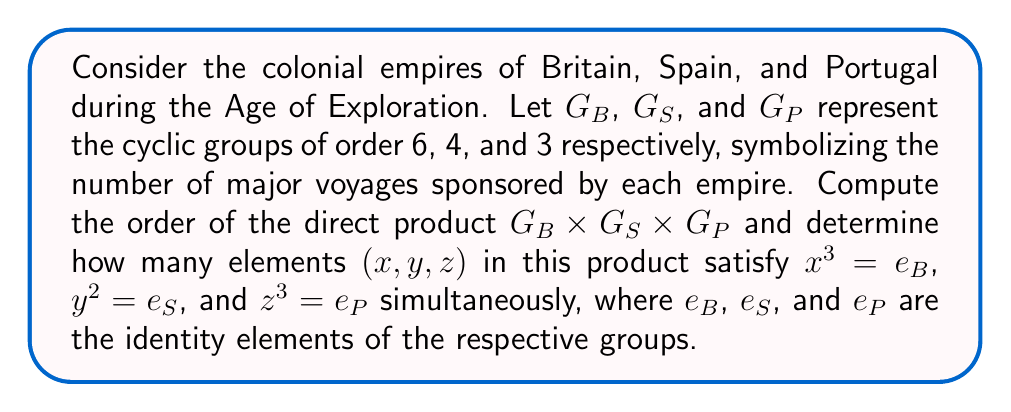Can you solve this math problem? Let's approach this step-by-step:

1) First, let's recall that for cyclic groups, the order of an element divides the order of the group. So:
   - In $G_B$, elements of order 1, 2, 3, and 6 exist
   - In $G_S$, elements of order 1, 2, and 4 exist
   - In $G_P$, elements of order 1 and 3 exist

2) The order of the direct product is the product of the orders of the individual groups:
   $$|G_B \times G_S \times G_P| = |G_B| \cdot |G_S| \cdot |G_P| = 6 \cdot 4 \cdot 3 = 72$$

3) Now, let's consider the conditions:
   - $x^3 = e_B$ is satisfied by elements of order 1, 2, 3, and 6 in $G_B$
   - $y^2 = e_S$ is satisfied by elements of order 1 and 2 in $G_S$
   - $z^3 = e_P$ is satisfied by all elements in $G_P$ (as $3^1 = 3$)

4) In $G_B$, there are 4 elements satisfying $x^3 = e_B$:
   - The identity element (order 1)
   - The element of order 2
   - Two elements of order 3

5) In $G_S$, there are 2 elements satisfying $y^2 = e_S$:
   - The identity element
   - The element of order 2

6) In $G_P$, all 3 elements satisfy $z^3 = e_P$

7) By the multiplication principle, the number of elements in the direct product satisfying all conditions simultaneously is:
   $$4 \cdot 2 \cdot 3 = 24$$

Thus, there are 24 elements in $G_B \times G_S \times G_P$ satisfying all the given conditions.
Answer: The order of $G_B \times G_S \times G_P$ is 72, and there are 24 elements $(x,y,z)$ in this direct product that simultaneously satisfy $x^3 = e_B$, $y^2 = e_S$, and $z^3 = e_P$. 